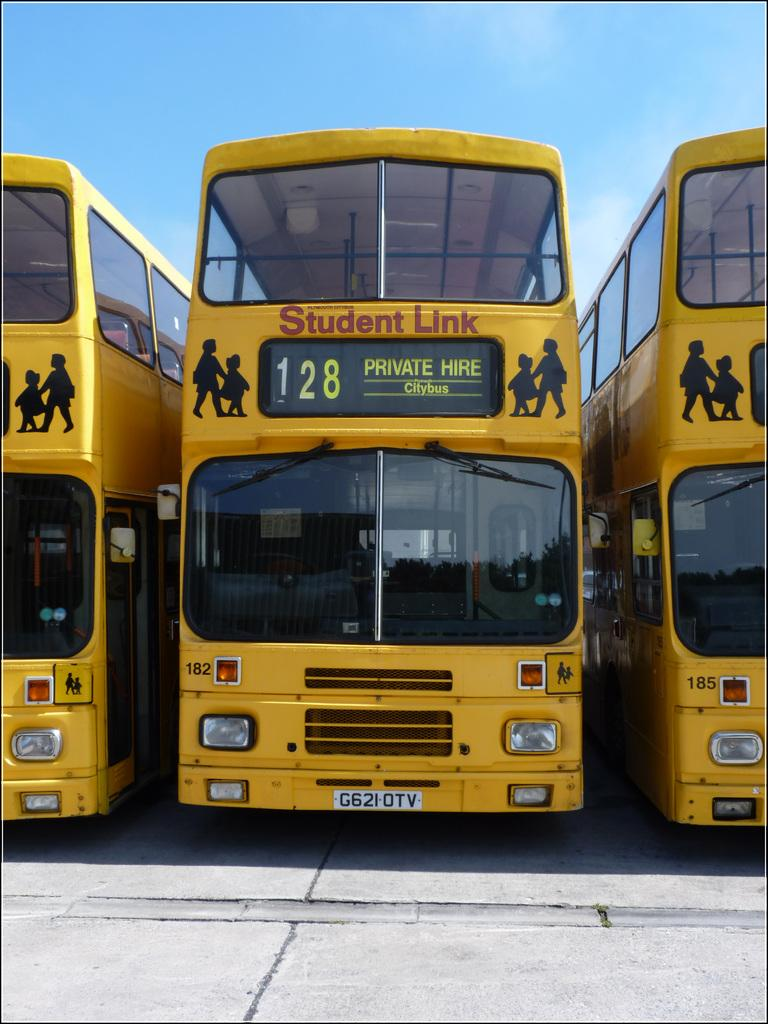What type of vehicles are present in the image? There are school buses in the image. Where are the buses located? The buses are parked on the ground. What features can be seen on the buses? There are headlights and mirrors on the buses. What can be seen in the background of the image? The sky is visible in the background of the image. What type of box is being used to read a book in the image? There is no box or book present in the image; it features school buses parked on the ground. What action are the buses performing in the image? The buses are parked on the ground, so they are not performing any action in the image. 